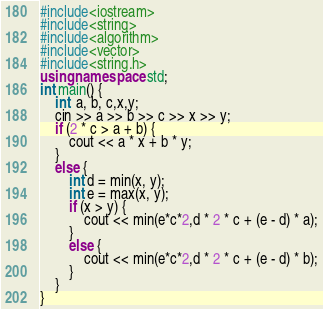<code> <loc_0><loc_0><loc_500><loc_500><_C++_>#include<iostream>
#include<string>
#include<algorithm>
#include<vector>
#include<string.h>
using namespace std;
int main() {
	int  a, b, c,x,y;
	cin >> a >> b >> c >> x >> y;
	if (2 * c > a + b) {
		cout << a * x + b * y;
	}
	else {
		int d = min(x, y);
		int e = max(x, y);
		if (x > y) {
			cout << min(e*c*2,d * 2 * c + (e - d) * a);
		}
		else {
			cout << min(e*c*2,d * 2 * c + (e - d) * b);
		}
	}
}
</code> 